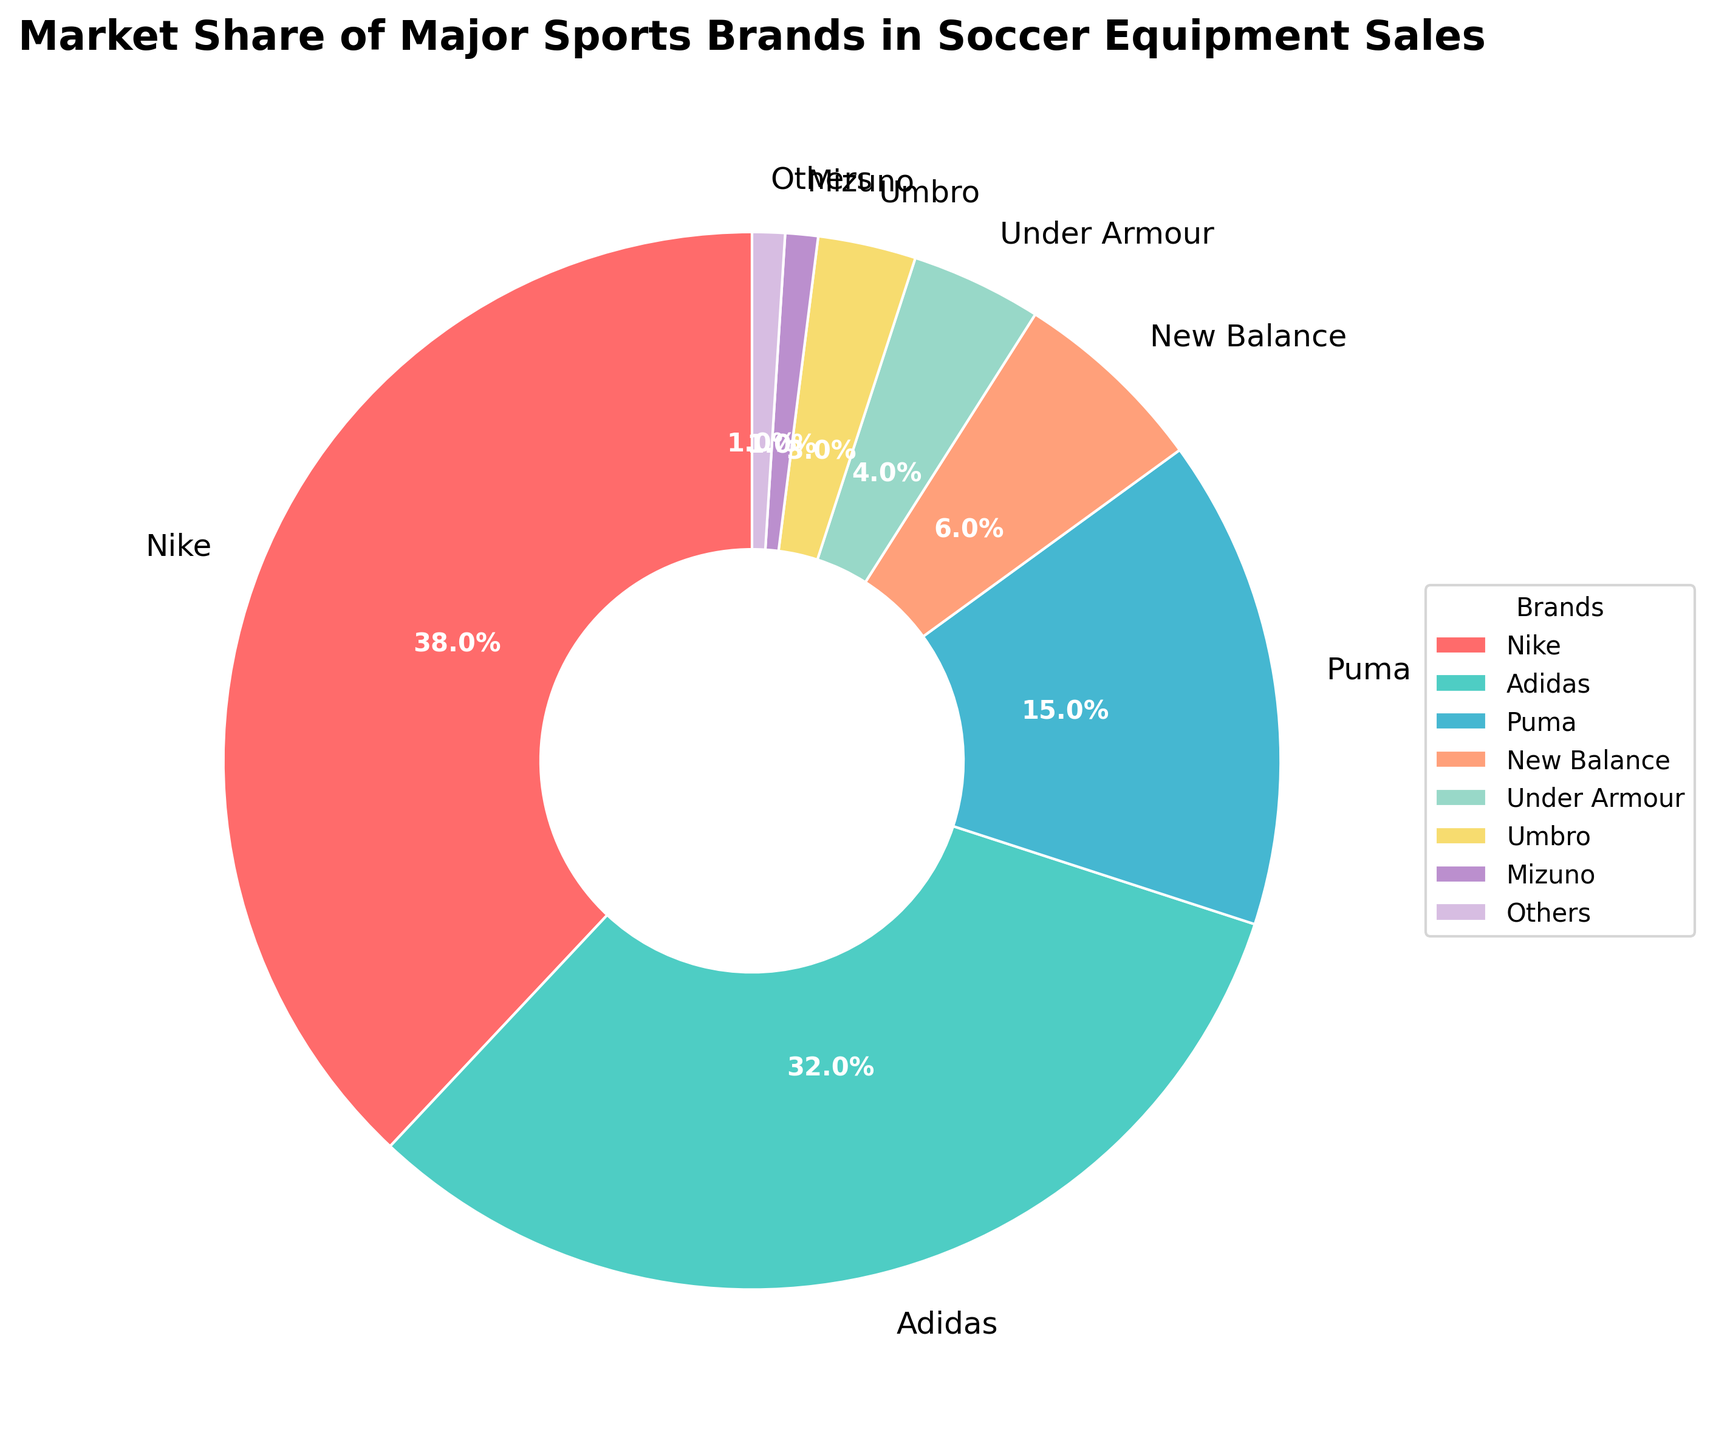Which brand has the largest market share? From the pie chart, the section for Nike is the largest. Therefore, Nike has the largest market share.
Answer: Nike What percentage of the market do Adidas and Nike together hold? According to the figure, Nike holds 38% of the market and Adidas holds 32%. Adding these together: 38% + 32% = 70%.
Answer: 70% Which brand has the smallest market share? The smallest section in the pie chart corresponds to "Others" and "Mizuno," both indicated with very small slices. Each has 1% market share.
Answer: Others, Mizuno How much larger is Nike's market share compared to Puma's? Nike has a 38% market share and Puma has 15%. The difference is found by subtracting Puma's share from Nike's share: 38% - 15% = 23%.
Answer: 23% Are there any brands with the same market share? The pie chart shows that "Others" and "Mizuno" both have a market share of 1%.
Answer: Yes What is the combined market share of small brands (New Balance, Under Armour, Umbro, Mizuno, Others)? From the figure, the market shares are as follows: New Balance (6%), Under Armour (4%), Umbro (3%), Mizuno (1%), Others (1%). Adding these: 6% + 4% + 3% + 1% + 1% = 15%.
Answer: 15% Which brand has a market share that is closest to half the market share of Nike? Nike's market share is 38%, half of this is 19%. Puma has a market share of 15%, which is closest to 19% when compared to the other brands.
Answer: Puma Is the market share of Under Armour greater than that of Mizuno and Umbro combined? Under Armour has a market share of 4%. Mizuno has 1% and Umbro has 3%, adding these gives: 1% + 3% = 4%. Therefore, Under Armour's share is equal to the combined share of Mizuno and Umbro.
Answer: No What color represents Adidas in the pie chart? The color associated with Adidas in the pie chart is a light turquoise or cyan color.
Answer: Cyan What's the difference in market share between the top three brands (Nike, Adidas, Puma) and the rest? The top three brands hold the following market shares: Nike (38%), Adidas (32%), and Puma (15%). Summing these: 38% + 32% + 15% = 85%. The rest (New Balance, Under Armour, Umbro, Mizuno, Others) together make up 15% of the market. The difference between the top three and the rest is: 85% - 15% = 70%.
Answer: 70% 